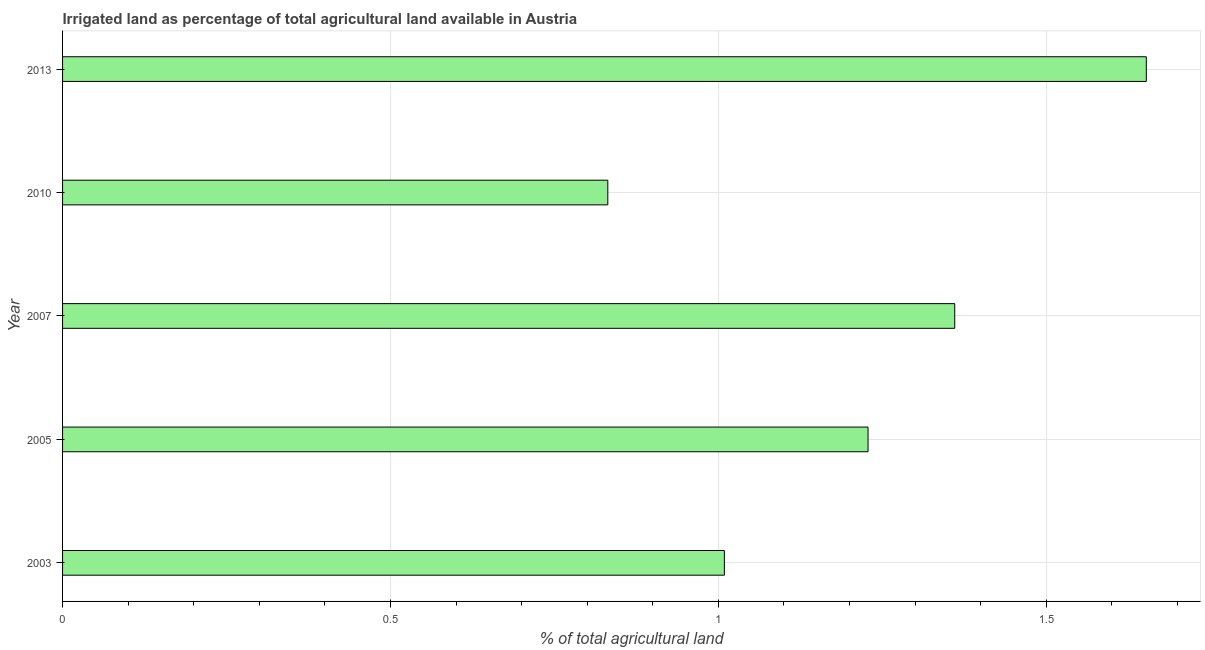Does the graph contain grids?
Provide a succinct answer. Yes. What is the title of the graph?
Offer a terse response. Irrigated land as percentage of total agricultural land available in Austria. What is the label or title of the X-axis?
Offer a terse response. % of total agricultural land. What is the label or title of the Y-axis?
Offer a terse response. Year. What is the percentage of agricultural irrigated land in 2003?
Offer a terse response. 1.01. Across all years, what is the maximum percentage of agricultural irrigated land?
Ensure brevity in your answer.  1.65. Across all years, what is the minimum percentage of agricultural irrigated land?
Offer a terse response. 0.83. What is the sum of the percentage of agricultural irrigated land?
Keep it short and to the point. 6.08. What is the difference between the percentage of agricultural irrigated land in 2005 and 2010?
Provide a short and direct response. 0.4. What is the average percentage of agricultural irrigated land per year?
Give a very brief answer. 1.22. What is the median percentage of agricultural irrigated land?
Provide a succinct answer. 1.23. In how many years, is the percentage of agricultural irrigated land greater than 1.1 %?
Provide a short and direct response. 3. Do a majority of the years between 2013 and 2005 (inclusive) have percentage of agricultural irrigated land greater than 0.6 %?
Your answer should be compact. Yes. What is the ratio of the percentage of agricultural irrigated land in 2005 to that in 2010?
Offer a terse response. 1.48. Is the difference between the percentage of agricultural irrigated land in 2003 and 2010 greater than the difference between any two years?
Your answer should be compact. No. What is the difference between the highest and the second highest percentage of agricultural irrigated land?
Offer a terse response. 0.29. Is the sum of the percentage of agricultural irrigated land in 2003 and 2007 greater than the maximum percentage of agricultural irrigated land across all years?
Your answer should be very brief. Yes. What is the difference between the highest and the lowest percentage of agricultural irrigated land?
Offer a very short reply. 0.82. In how many years, is the percentage of agricultural irrigated land greater than the average percentage of agricultural irrigated land taken over all years?
Your answer should be compact. 3. How many bars are there?
Ensure brevity in your answer.  5. What is the difference between two consecutive major ticks on the X-axis?
Your response must be concise. 0.5. What is the % of total agricultural land of 2003?
Make the answer very short. 1.01. What is the % of total agricultural land in 2005?
Provide a succinct answer. 1.23. What is the % of total agricultural land of 2007?
Give a very brief answer. 1.36. What is the % of total agricultural land of 2010?
Ensure brevity in your answer.  0.83. What is the % of total agricultural land in 2013?
Offer a terse response. 1.65. What is the difference between the % of total agricultural land in 2003 and 2005?
Your response must be concise. -0.22. What is the difference between the % of total agricultural land in 2003 and 2007?
Make the answer very short. -0.35. What is the difference between the % of total agricultural land in 2003 and 2010?
Provide a short and direct response. 0.18. What is the difference between the % of total agricultural land in 2003 and 2013?
Your answer should be compact. -0.64. What is the difference between the % of total agricultural land in 2005 and 2007?
Provide a short and direct response. -0.13. What is the difference between the % of total agricultural land in 2005 and 2010?
Your answer should be very brief. 0.4. What is the difference between the % of total agricultural land in 2005 and 2013?
Offer a terse response. -0.42. What is the difference between the % of total agricultural land in 2007 and 2010?
Offer a terse response. 0.53. What is the difference between the % of total agricultural land in 2007 and 2013?
Ensure brevity in your answer.  -0.29. What is the difference between the % of total agricultural land in 2010 and 2013?
Your answer should be very brief. -0.82. What is the ratio of the % of total agricultural land in 2003 to that in 2005?
Provide a short and direct response. 0.82. What is the ratio of the % of total agricultural land in 2003 to that in 2007?
Offer a very short reply. 0.74. What is the ratio of the % of total agricultural land in 2003 to that in 2010?
Ensure brevity in your answer.  1.21. What is the ratio of the % of total agricultural land in 2003 to that in 2013?
Make the answer very short. 0.61. What is the ratio of the % of total agricultural land in 2005 to that in 2007?
Provide a succinct answer. 0.9. What is the ratio of the % of total agricultural land in 2005 to that in 2010?
Give a very brief answer. 1.48. What is the ratio of the % of total agricultural land in 2005 to that in 2013?
Provide a succinct answer. 0.74. What is the ratio of the % of total agricultural land in 2007 to that in 2010?
Your response must be concise. 1.64. What is the ratio of the % of total agricultural land in 2007 to that in 2013?
Offer a very short reply. 0.82. What is the ratio of the % of total agricultural land in 2010 to that in 2013?
Your answer should be very brief. 0.5. 